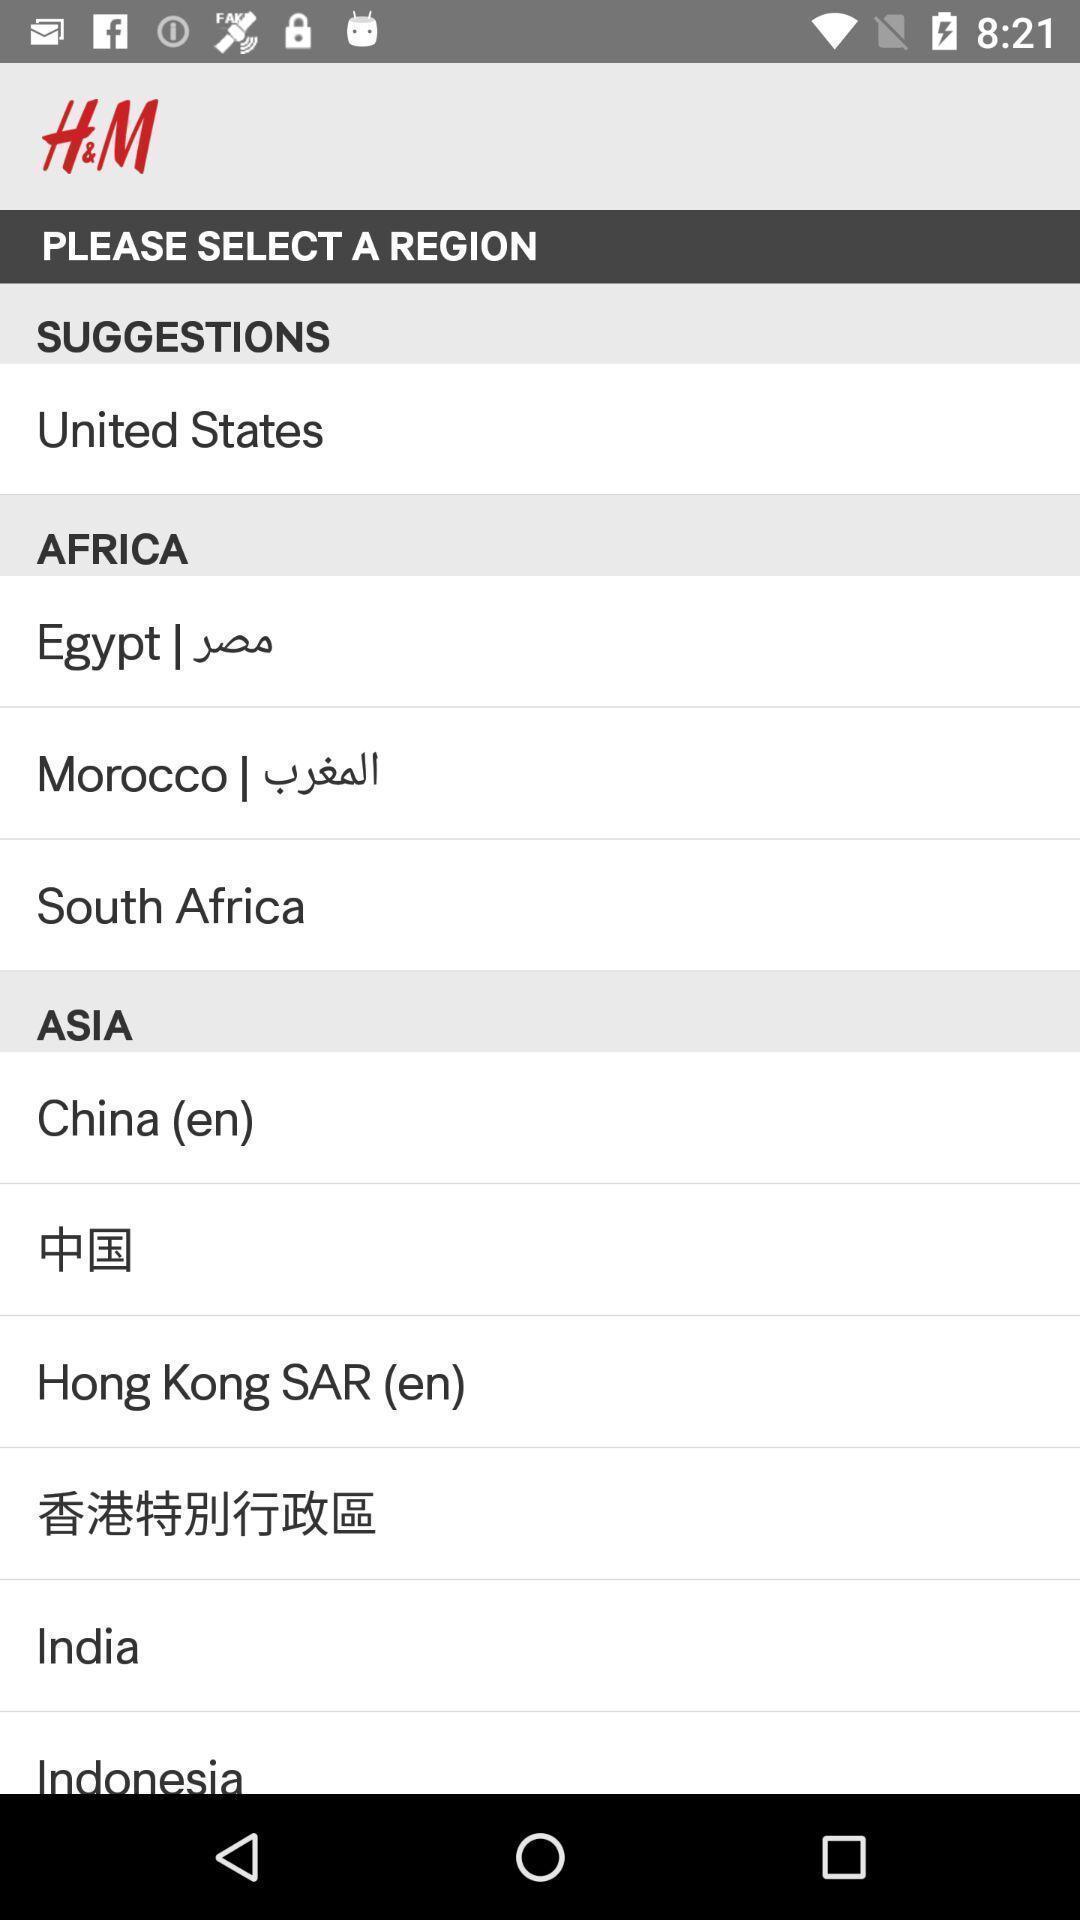What can you discern from this picture? Screen shows list of options. 